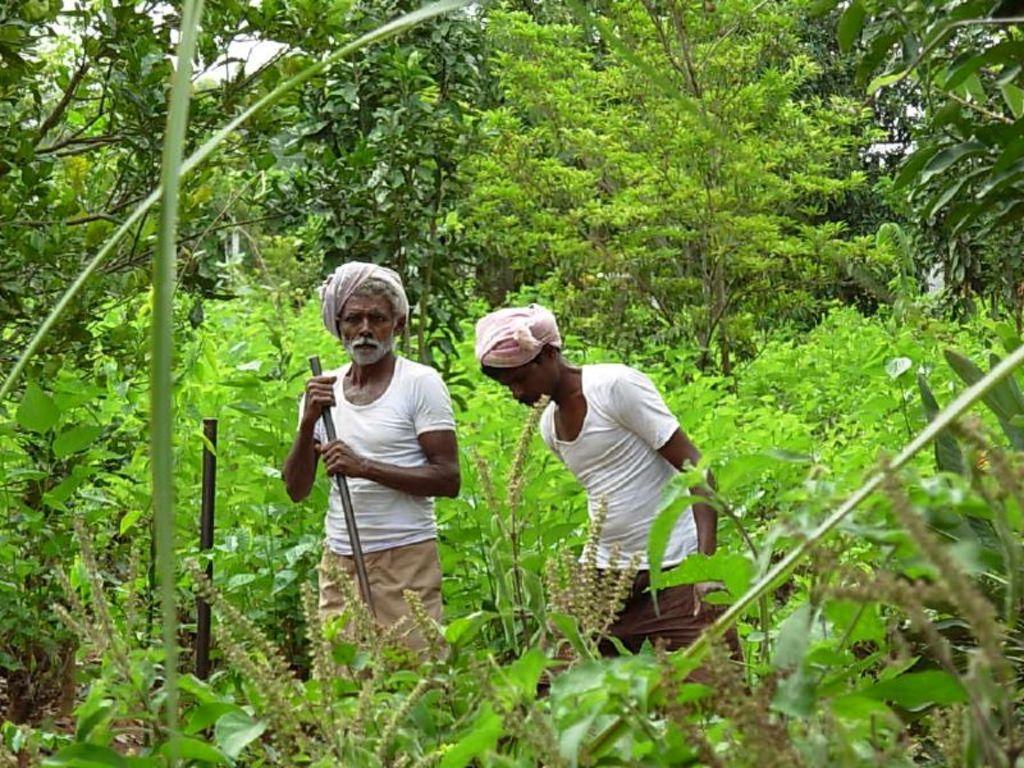Can you describe this image briefly? In the center of the image there are persons standing. In the background of the image there are trees. There are plants. 